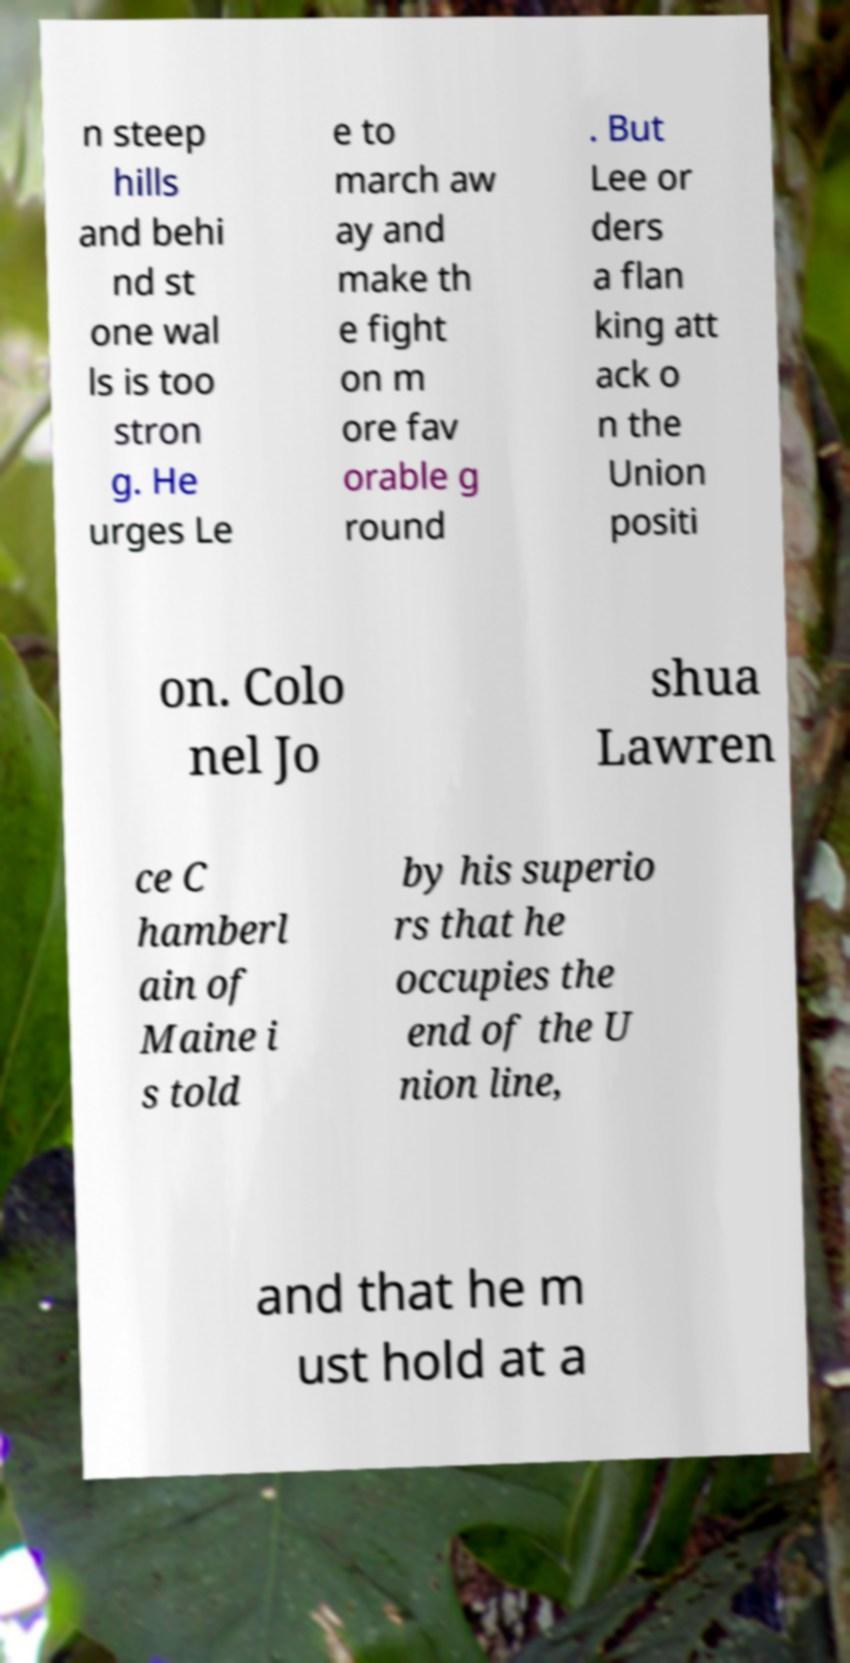For documentation purposes, I need the text within this image transcribed. Could you provide that? n steep hills and behi nd st one wal ls is too stron g. He urges Le e to march aw ay and make th e fight on m ore fav orable g round . But Lee or ders a flan king att ack o n the Union positi on. Colo nel Jo shua Lawren ce C hamberl ain of Maine i s told by his superio rs that he occupies the end of the U nion line, and that he m ust hold at a 